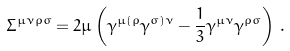Convert formula to latex. <formula><loc_0><loc_0><loc_500><loc_500>\Sigma ^ { \mu \nu \rho \sigma } = 2 \mu \left ( \gamma ^ { \mu ( \rho } \gamma ^ { \sigma ) \nu } - \frac { 1 } { 3 } \gamma ^ { \mu \nu } \gamma ^ { \rho \sigma } \right ) \, .</formula> 